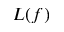Convert formula to latex. <formula><loc_0><loc_0><loc_500><loc_500>L ( f )</formula> 